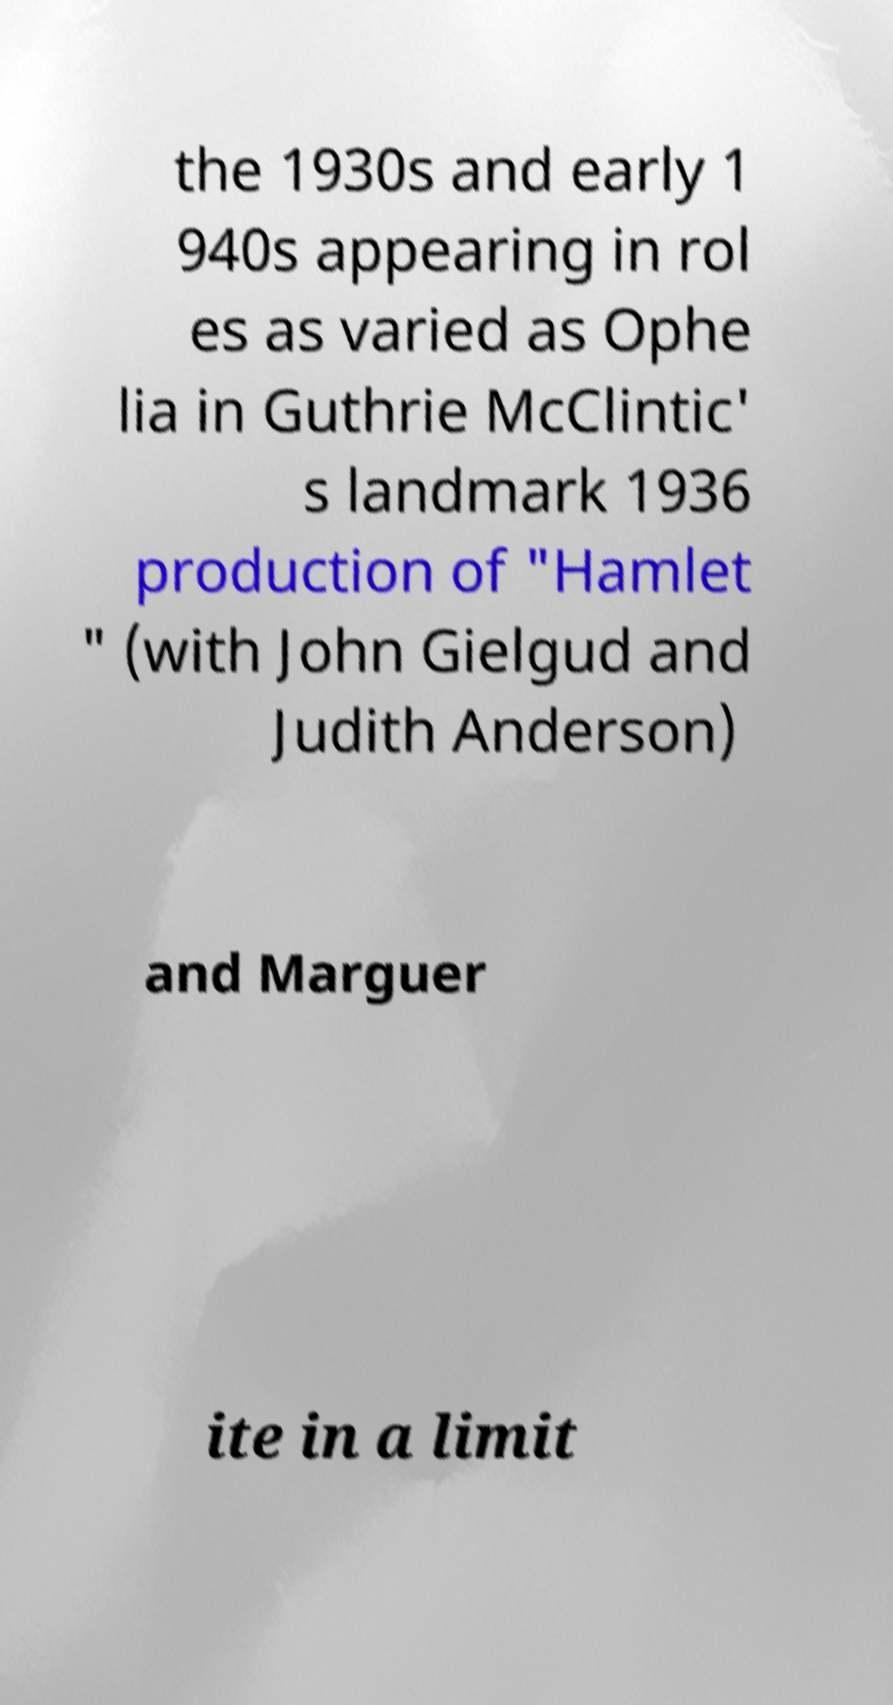Could you assist in decoding the text presented in this image and type it out clearly? the 1930s and early 1 940s appearing in rol es as varied as Ophe lia in Guthrie McClintic' s landmark 1936 production of "Hamlet " (with John Gielgud and Judith Anderson) and Marguer ite in a limit 